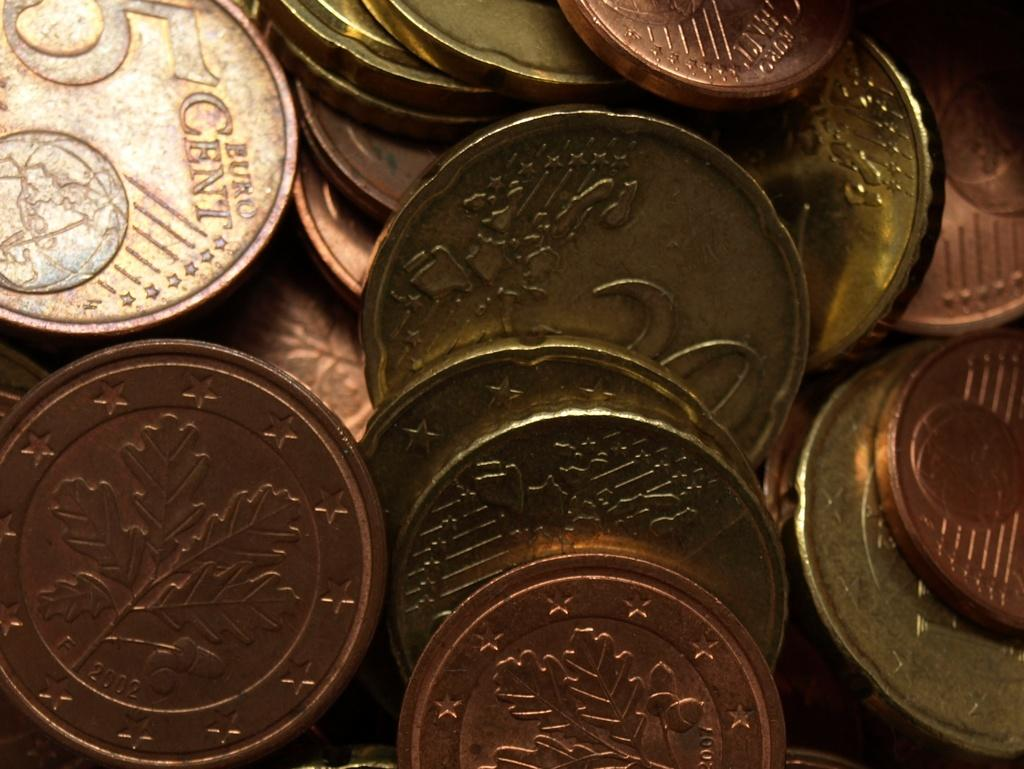<image>
Relay a brief, clear account of the picture shown. A collection of coins, one of which was minted in 2002. 